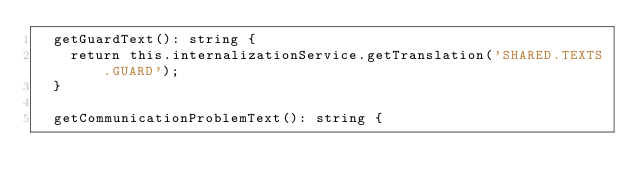<code> <loc_0><loc_0><loc_500><loc_500><_TypeScript_>  getGuardText(): string {
    return this.internalizationService.getTranslation('SHARED.TEXTS.GUARD');
  }

  getCommunicationProblemText(): string {</code> 